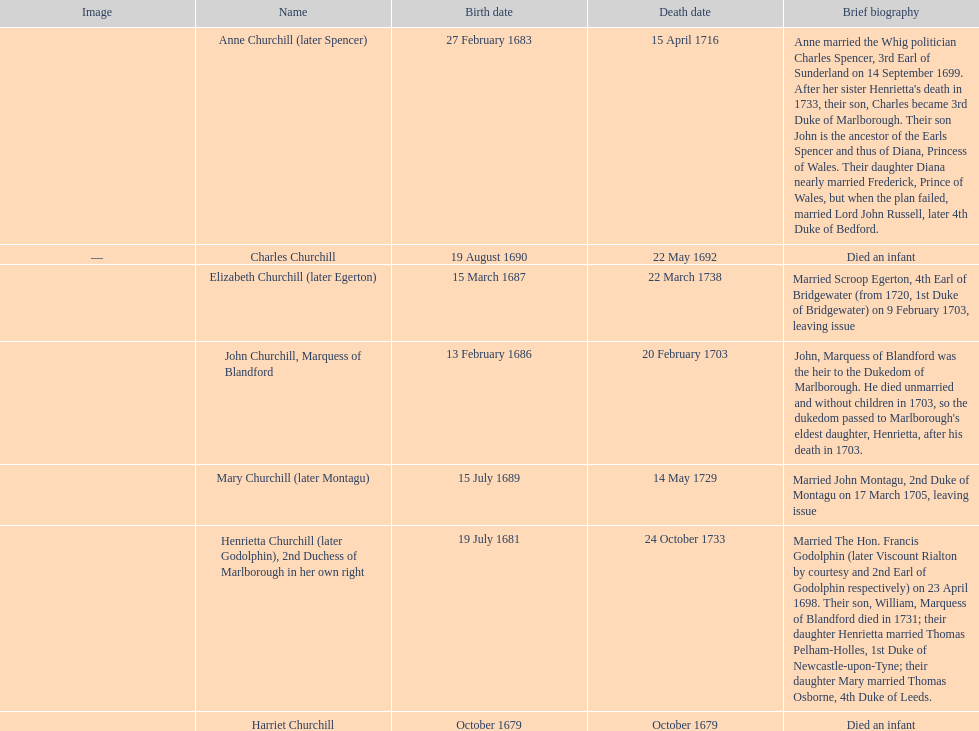What was the birthdate of sarah churchill's first child? October 1679. 